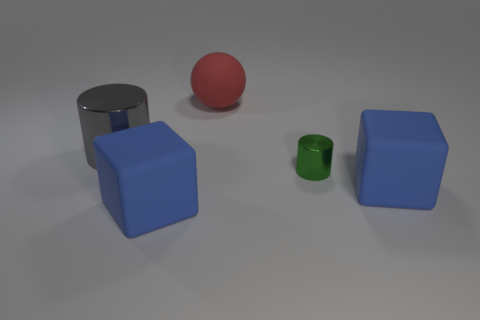What can you infer about the reflections on the surfaces of the objects? The reflections indicate that the objects have varying degrees of shininess. The gray cylinder has a high reflective surface, which suggests it's made of a material like metal. The blue cubes have a less reflective surface, hinting at a matte or plastic finish. 